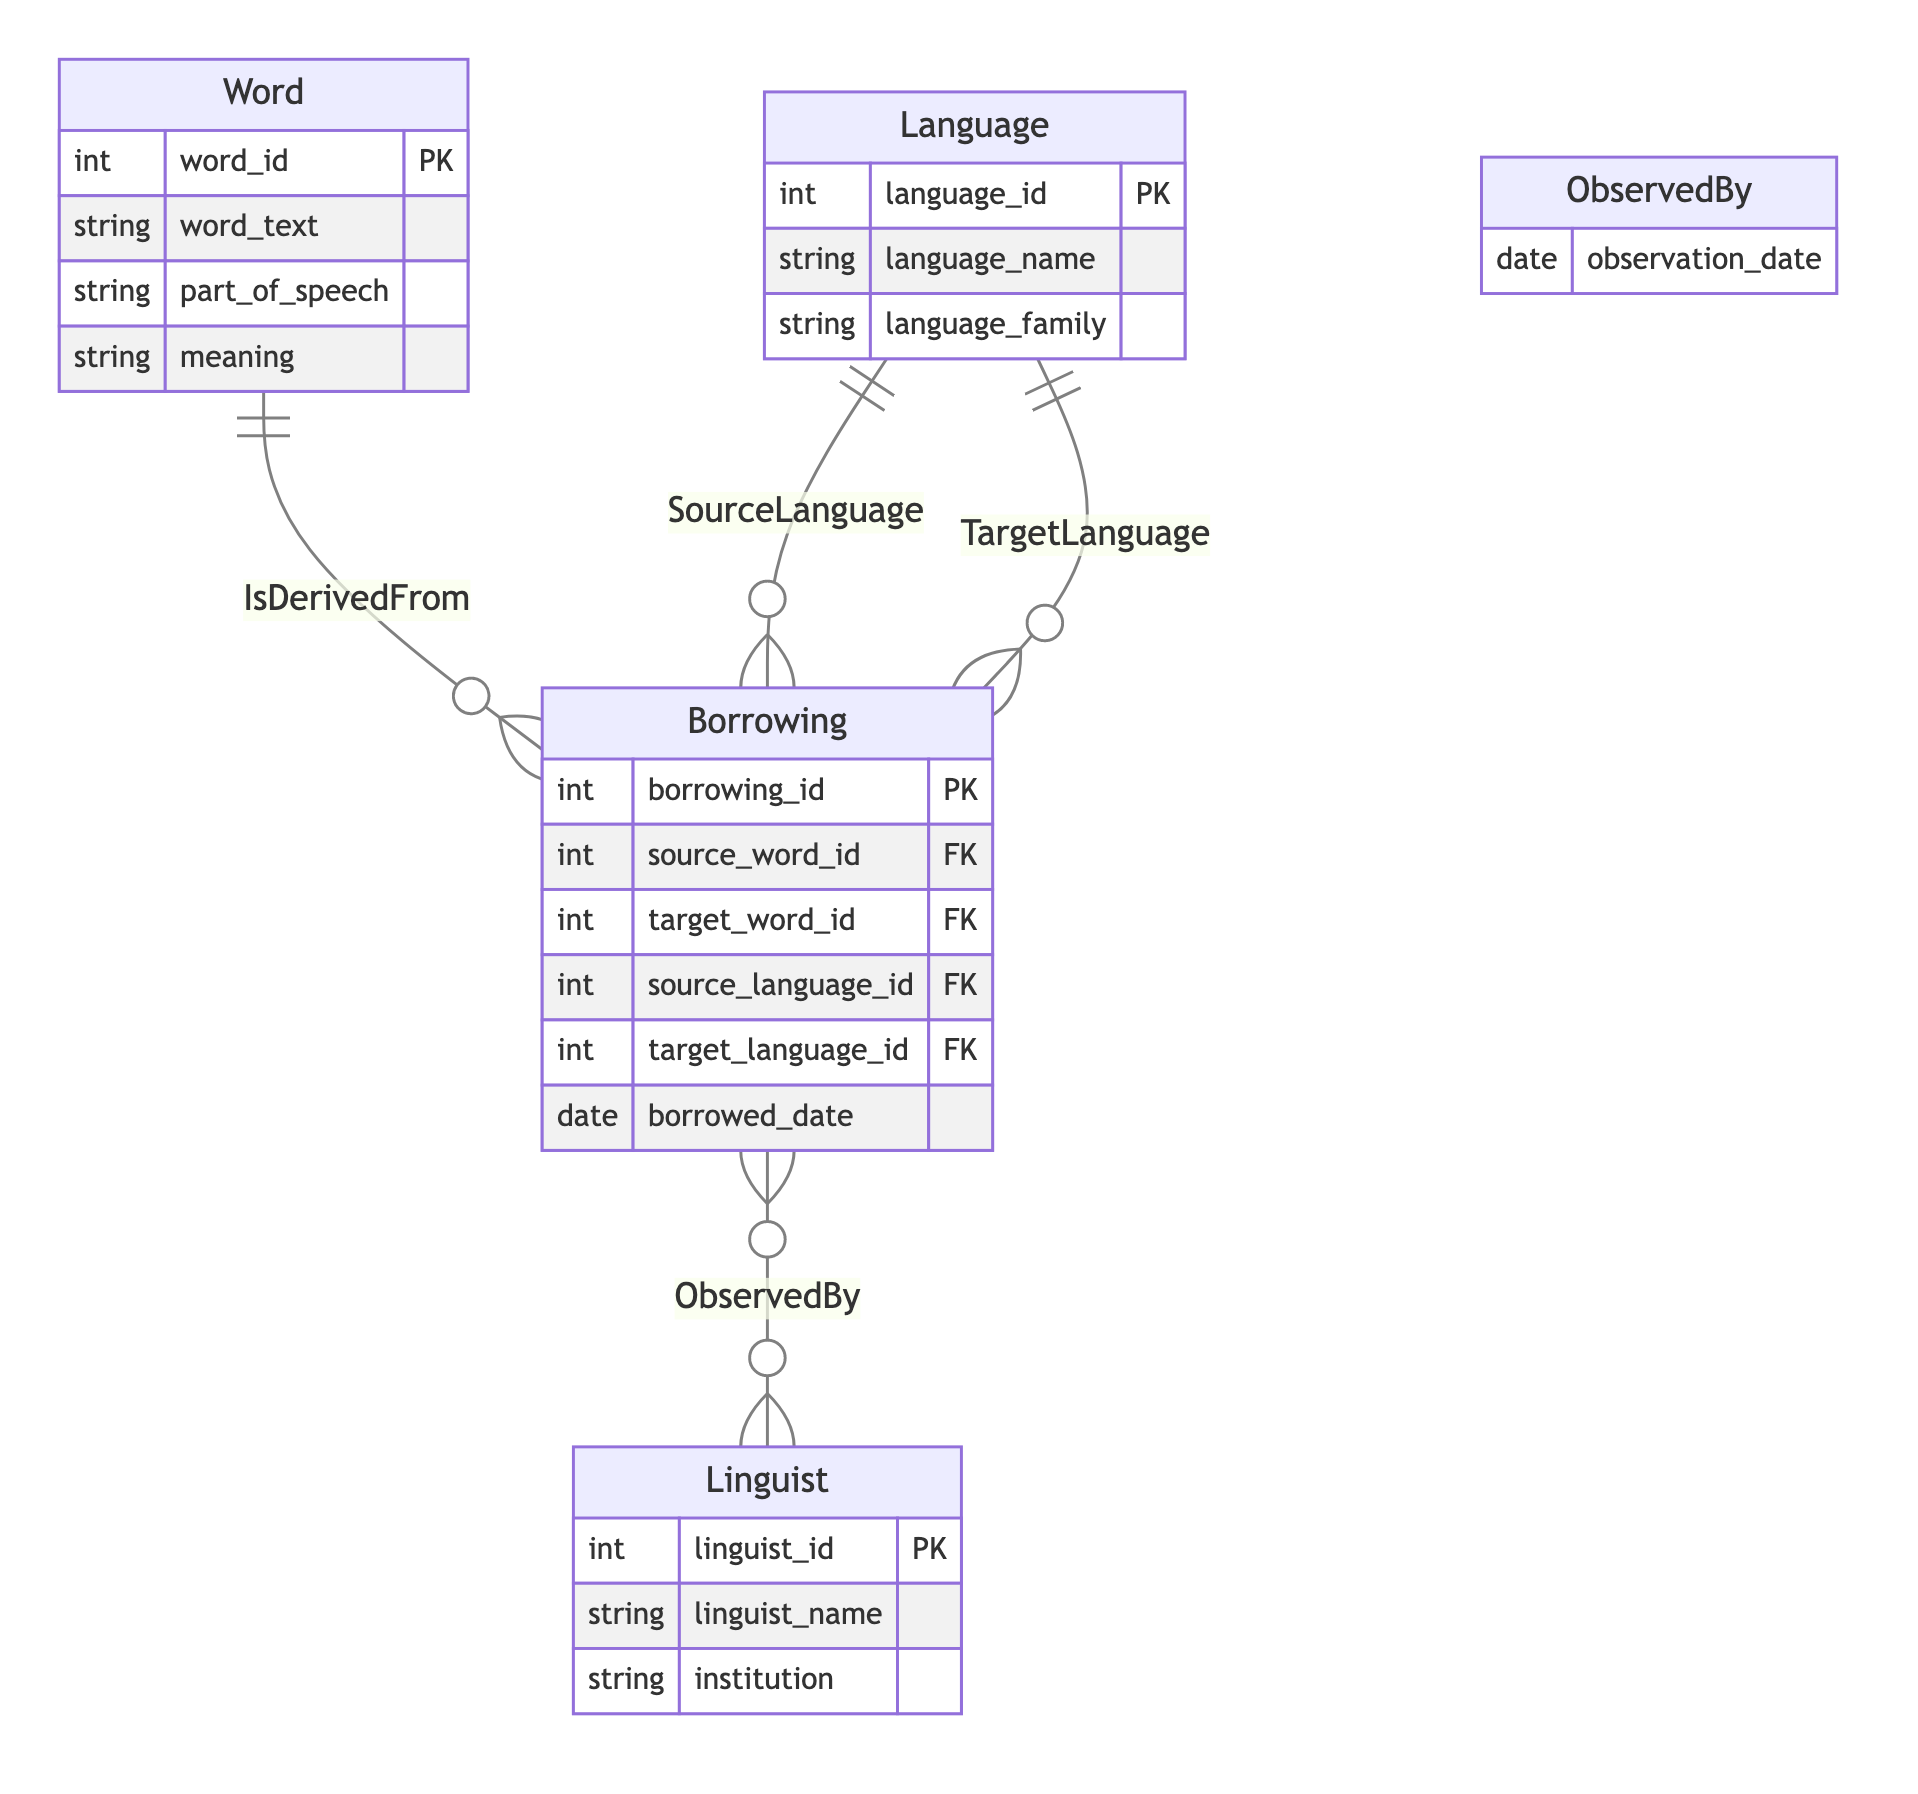What is the primary key of the Word entity? The primary key of the Word entity is defined as "word_id". This can be identified by looking at the attributes listed under the Word entity in the diagram, where "word_id" is marked as the primary key (PK).
Answer: word_id How many entities are present in the diagram? The diagram features four entities: Word, Language, Borrowing, and Linguist. To ascertain this, one can count the distinct entity blocks in the diagram.
Answer: four What relationship exists between Borrowing and Linguist? The relationship between Borrowing and Linguist is named "ObservedBy". This is evidenced by the relationship line connecting these two entities in the diagram, along with its label.
Answer: ObservedBy What type of relationship is SourceLanguage? The SourceLanguage relationship is a "many-to-one" relationship. This can be determined from the relationship annotation on the line connecting Borrowing with Language, indicating that many Borrowing records can relate to one Language.
Answer: many-to-one How many attributes are there in the Borrowing entity? The Borrowing entity contains five attributes: borrowing_id, source_word_id, target_word_id, source_language_id, and target_language_id. Counting these will confirm the total number of attributes in this entity.
Answer: five Which entity has the attribute 'institution'? The entity with the attribute 'institution' is the Linguist entity. This can be seen by inspecting the list of attributes under each entity where 'institution' is specifically listed with the Linguist entity.
Answer: Linguist What does the relationship IsDerivedFrom indicate? The IsDerivedFrom relationship indicates that each Borrowing is associated with one specific Word they are derived from. It signifies a one-to-one connection between Borrowing and Word in the diagram, clarifying the nature of lexical borrowing.
Answer: a one-to-one connection What information does the observation_date attribute provide? The observation_date attribute provides information about when the Borrowing was observed by a Linguist. This can be inferred from the context of the ObservedBy relationship, which includes this specific attribute as part of its definition.
Answer: date of observation Which language family does the Language entity include? The Language entity includes the attribute 'language_family', which signifies various language families represented within the Language data. However, the specific families are not detailed in the diagram; the answer pertains to the attribute itself.
Answer: language_family 